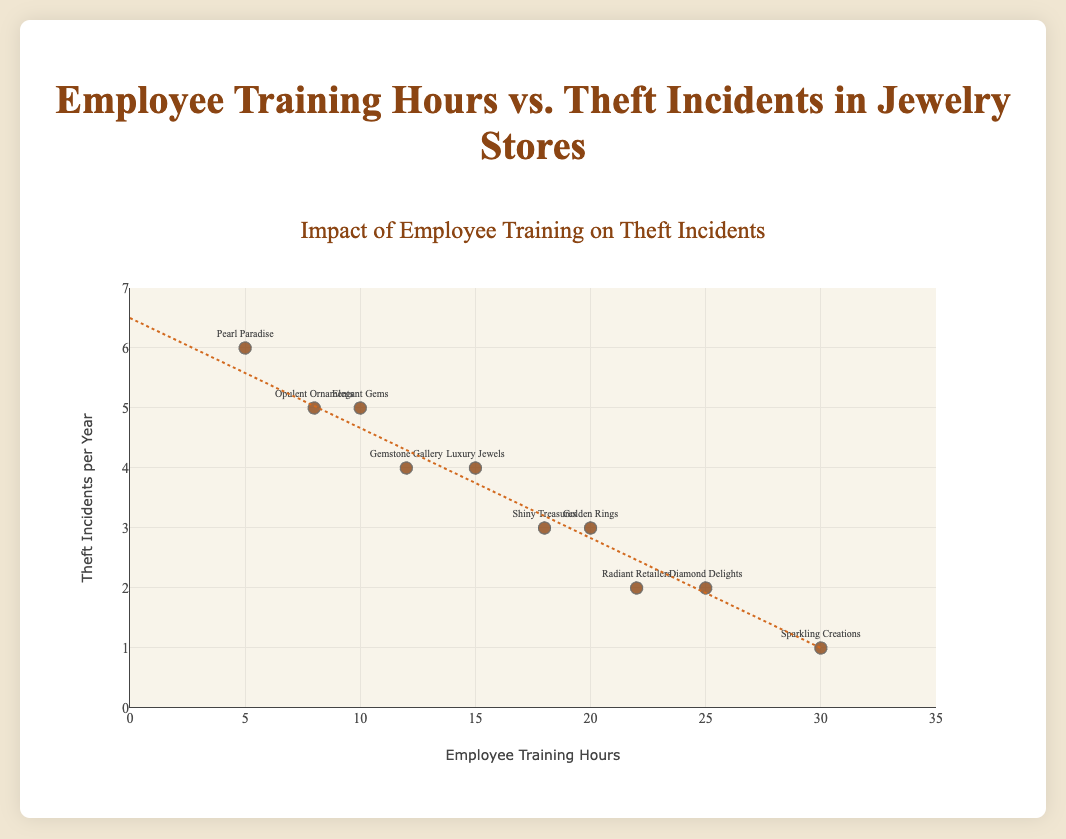What is the title of the figure? The title of the figure is displayed at the top and it is "Impact of Employee Training on Theft Incidents".
Answer: Impact of Employee Training on Theft Incidents How many stores are represented in the figure? The figure has data points with text labels for each store, and counting the labels gives us the total number of stores.
Answer: 10 stores Which store has the highest number of theft incidents per year? By looking at the y-axis and the data points, "Pearl Paradise" at 5 hours of training has the highest theft incidents per year, which is 6.
Answer: Pearl Paradise Which store has the lowest number of theft incidents per year? By checking the y-axis and corresponding data points, "Sparkling Creations" at 30 training hours has the lowest theft incidents per year, which is 1.
Answer: Sparkling Creations Which store has the highest number of employee training hours? By looking at the x-axis and the data points, "Sparkling Creations" has the highest training hours at 30.
Answer: Sparkling Creations Is there a general trend visible between employee training hours and theft incidents? The trend line in the figure shows a downward slope, suggesting that as employee training hours increase, theft incidents per year tend to decrease.
Answer: Theft incidents decrease with more training hours How many stores have more than 15 employee training hours? By counting the data points on the x-axis that are above 15 training hours: Golden Rings, Diamond Delights, Sparkling Creations, Shiny Treasures, Radiant Retailers.
Answer: 5 stores Which two stores have the same number of training hours but different theft incidents? Checking the data points, "Elegant Gems" and "Opulent Ornaments" both have 10 training hours but 5 and 4 theft incidents respectively.
Answer: Elegant Gems and Opulent Ornaments What are the coordinates of the store with 22 employee training hours? The store with 22 training hours is "Radiant Retailers", and its coordinates are (22, 2).
Answer: (22, 2) If a new store was added with 28 training hours and 1 theft incident per year, how would this data point affect the trend line? Adding a data point near the end of the x-axis with low theft incidents would likely reinforce the downward trend of theft incidents with increasing training hours.
Answer: Reinforce downward trend 